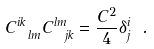<formula> <loc_0><loc_0><loc_500><loc_500>C _ { \ l m } ^ { i k } C _ { \ j k } ^ { l m } = \frac { C ^ { 2 } } { 4 } \delta _ { j } ^ { i } \ .</formula> 